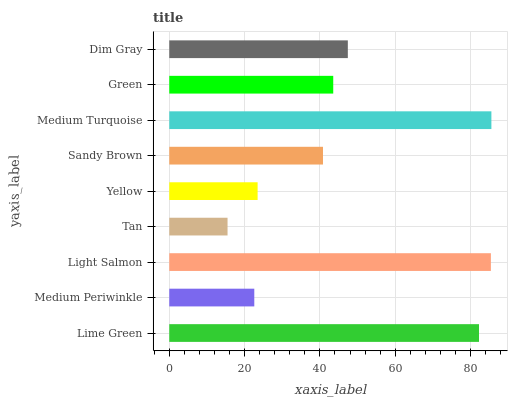Is Tan the minimum?
Answer yes or no. Yes. Is Medium Turquoise the maximum?
Answer yes or no. Yes. Is Medium Periwinkle the minimum?
Answer yes or no. No. Is Medium Periwinkle the maximum?
Answer yes or no. No. Is Lime Green greater than Medium Periwinkle?
Answer yes or no. Yes. Is Medium Periwinkle less than Lime Green?
Answer yes or no. Yes. Is Medium Periwinkle greater than Lime Green?
Answer yes or no. No. Is Lime Green less than Medium Periwinkle?
Answer yes or no. No. Is Green the high median?
Answer yes or no. Yes. Is Green the low median?
Answer yes or no. Yes. Is Yellow the high median?
Answer yes or no. No. Is Medium Turquoise the low median?
Answer yes or no. No. 